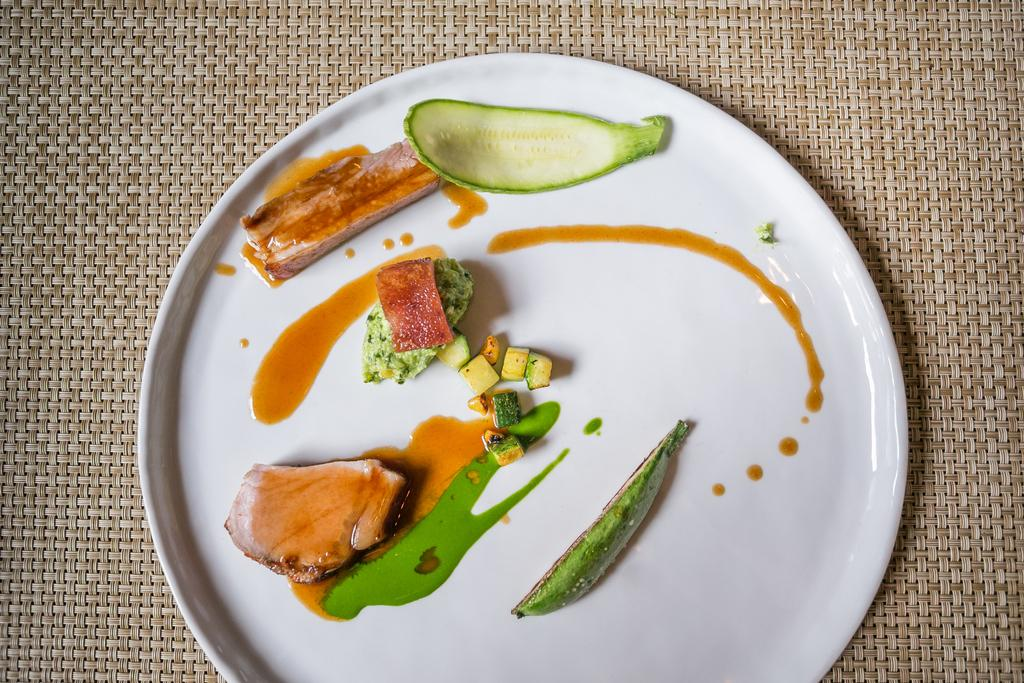What is on the white plate in the image? There is food on a white plate in the image. What is located beneath the plate in the image? There is a table mat at the bottom of the image. What type of horn can be seen on the table in the image? There is no horn present in the image. What kind of stone is used as a decorative element in the image? There is no stone present in the image. 